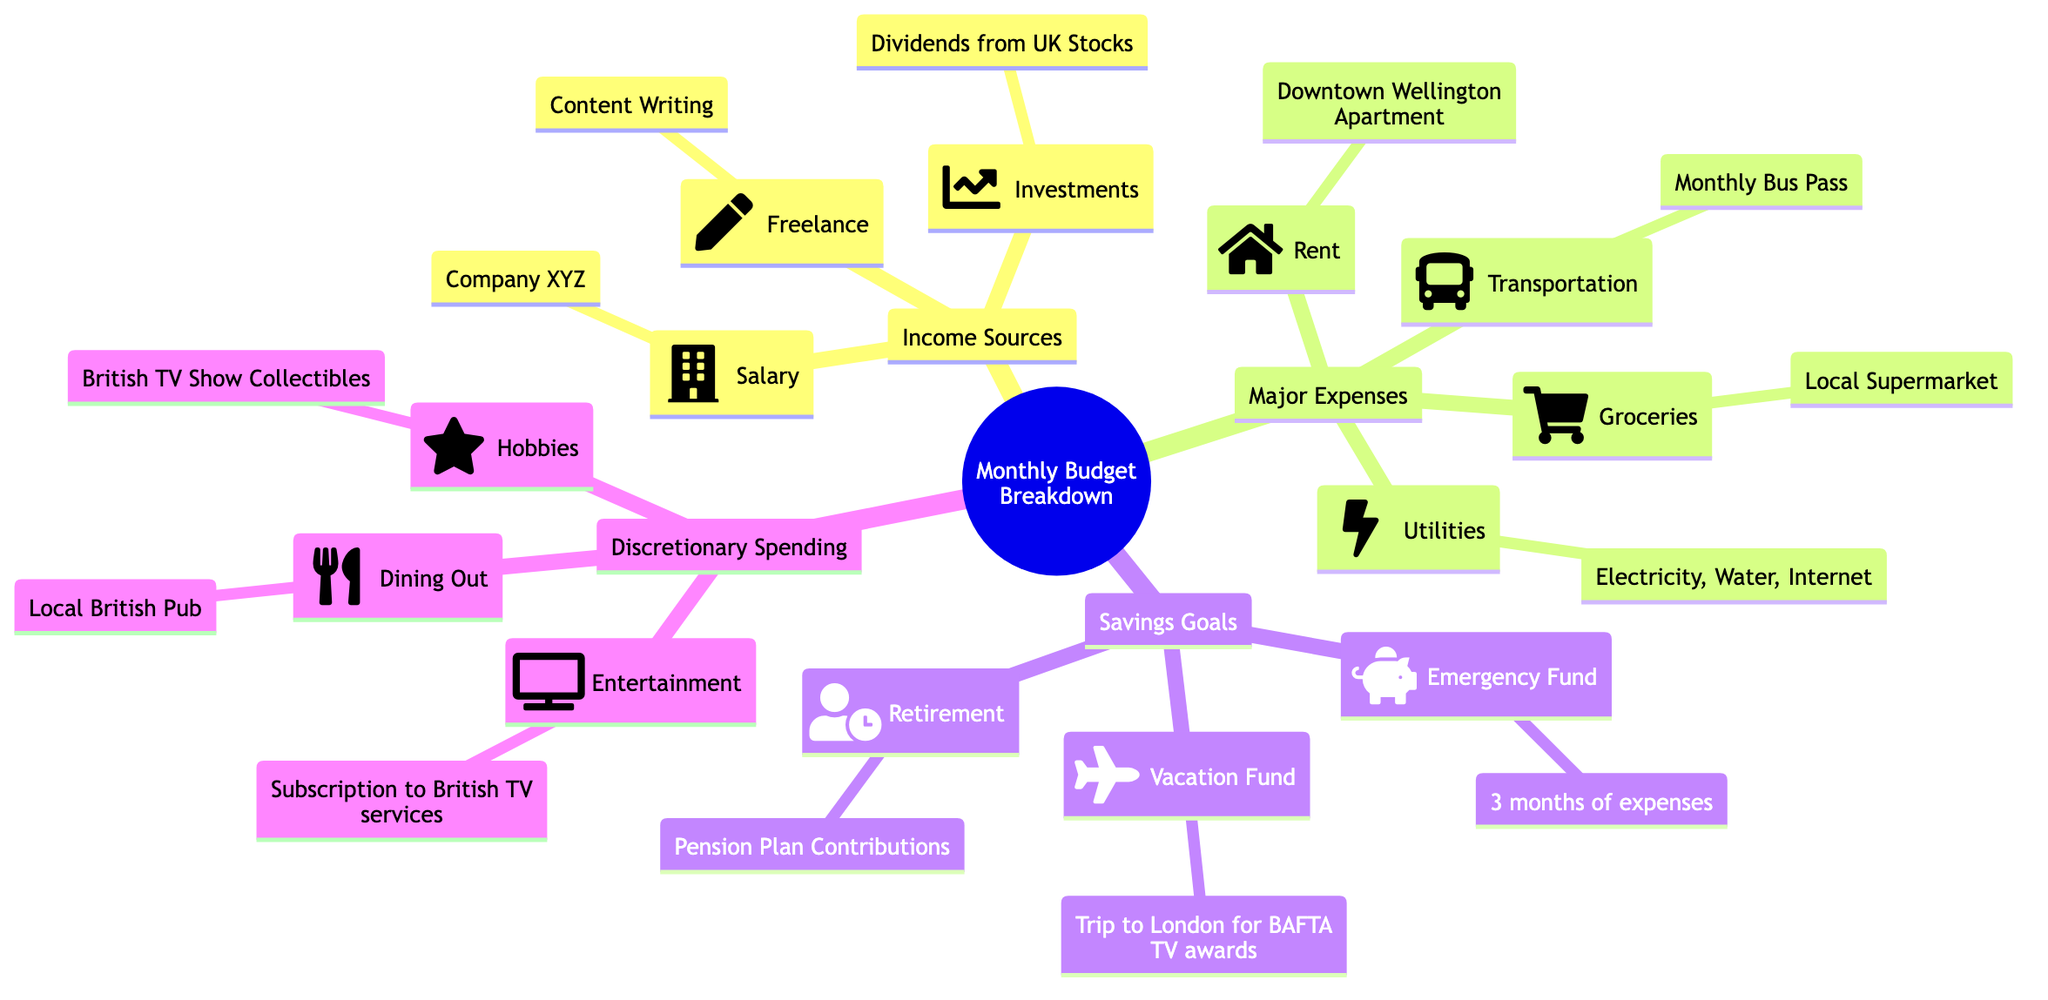What are the three main sources of income? The diagram lists three income sources under "Income Sources": Salary from Company XYZ, Freelance work in Content Writing, and Investments from Dividends from UK Stocks. By identifying these categories, we can pinpoint the specific sources of income mentioned.
Answer: Salary, Freelance, Investments How many major expenses are listed? The "Major Expenses" section of the mind map contains four items: Rent, Utilities, Groceries, and Transportation. By counting these items, we can determine the total number of major expenses.
Answer: 4 What is the purpose of the savings goal labeled "Vacation Fund"? Under "Savings Goals," the "Vacation Fund" is specifically stated to be for a trip to London for the BAFTA TV awards. This label clearly indicates the intended use of the funds.
Answer: Trip to London for BAFTA TV awards Which major expense is related to housing? The "Rent" is identified as a major expense in the diagram, specifically associated with the Downtown Wellington Apartment. This indicates the relationship between housing and the expense.
Answer: Rent What type of discretionary spending is mentioned related to hobbies? In the "Discretionary Spending" category, "Hobbies" are linked to "British TV Show Collectibles." This specifies the particular focus of hobby-related spending.
Answer: British TV Show Collectibles Which income source is from investments? The diagram explicitly labels "Dividends from UK Stocks" under "Investments" as a source of income. This directly connects the income source to its category.
Answer: Dividends from UK Stocks How many savings goals are specified in the diagram? The "Savings Goals" section contains three items: Emergency Fund, Vacation Fund, and Retirement. Counting these will reveal the total number of savings goals set.
Answer: 3 What is the utility expense that requires regular payment? The diagram lists "Utilities" as a major expense, which includes Electricity, Water, and Internet. Therefore, the utility expense encompasses these regular bills.
Answer: Electricity, Water, Internet Which discretionary spending category includes dining out? The "Dining Out" category is specified under "Discretionary Spending," which indicates a focus on eating out as a leisure activity.
Answer: Local British Pub 